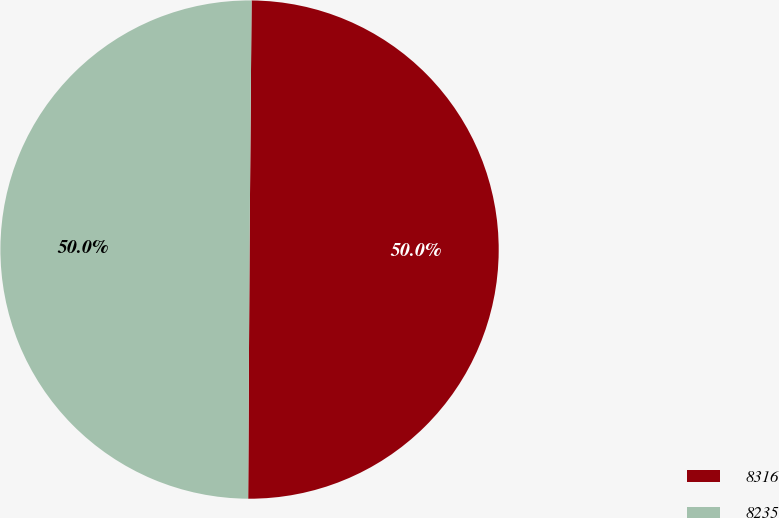Convert chart. <chart><loc_0><loc_0><loc_500><loc_500><pie_chart><fcel>8316<fcel>8235<nl><fcel>49.96%<fcel>50.04%<nl></chart> 